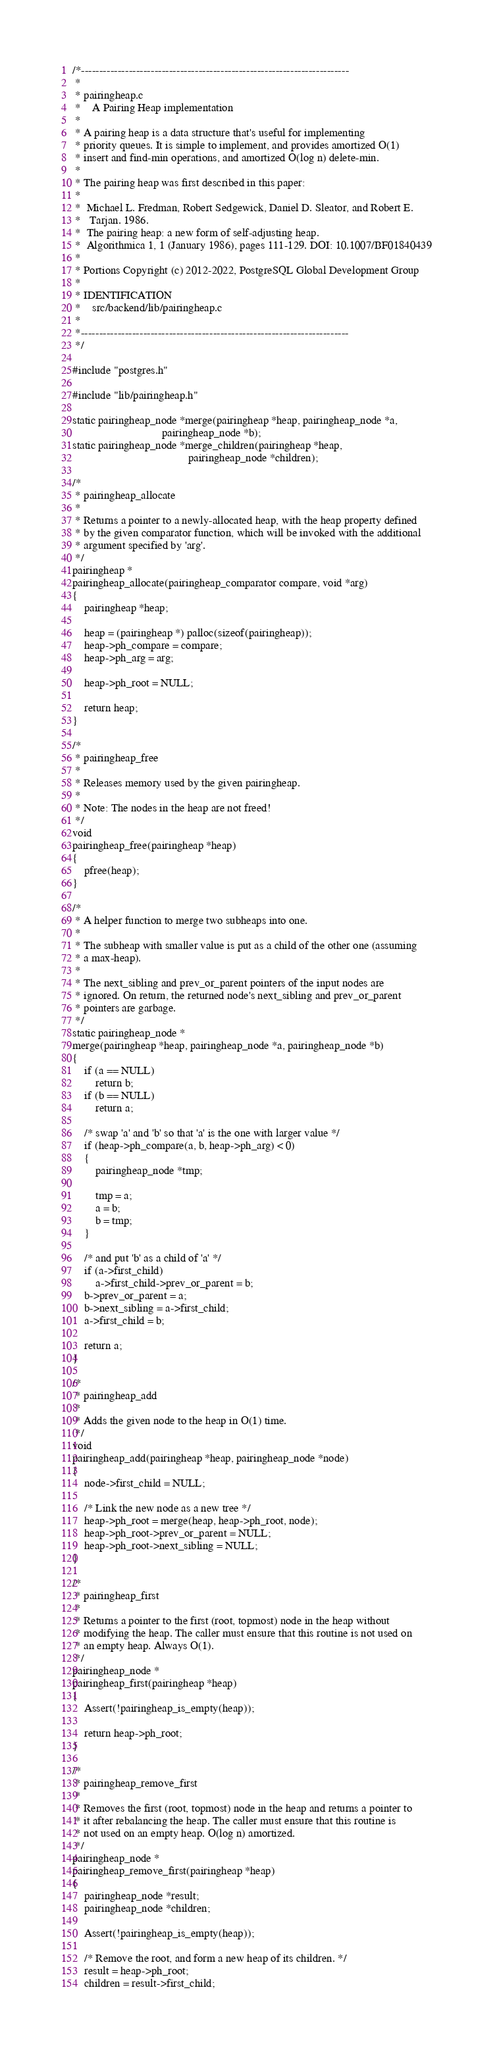<code> <loc_0><loc_0><loc_500><loc_500><_C_>/*-------------------------------------------------------------------------
 *
 * pairingheap.c
 *	  A Pairing Heap implementation
 *
 * A pairing heap is a data structure that's useful for implementing
 * priority queues. It is simple to implement, and provides amortized O(1)
 * insert and find-min operations, and amortized O(log n) delete-min.
 *
 * The pairing heap was first described in this paper:
 *
 *	Michael L. Fredman, Robert Sedgewick, Daniel D. Sleator, and Robert E.
 *	 Tarjan. 1986.
 *	The pairing heap: a new form of self-adjusting heap.
 *	Algorithmica 1, 1 (January 1986), pages 111-129. DOI: 10.1007/BF01840439
 *
 * Portions Copyright (c) 2012-2022, PostgreSQL Global Development Group
 *
 * IDENTIFICATION
 *	  src/backend/lib/pairingheap.c
 *
 *-------------------------------------------------------------------------
 */

#include "postgres.h"

#include "lib/pairingheap.h"

static pairingheap_node *merge(pairingheap *heap, pairingheap_node *a,
							   pairingheap_node *b);
static pairingheap_node *merge_children(pairingheap *heap,
										pairingheap_node *children);

/*
 * pairingheap_allocate
 *
 * Returns a pointer to a newly-allocated heap, with the heap property defined
 * by the given comparator function, which will be invoked with the additional
 * argument specified by 'arg'.
 */
pairingheap *
pairingheap_allocate(pairingheap_comparator compare, void *arg)
{
	pairingheap *heap;

	heap = (pairingheap *) palloc(sizeof(pairingheap));
	heap->ph_compare = compare;
	heap->ph_arg = arg;

	heap->ph_root = NULL;

	return heap;
}

/*
 * pairingheap_free
 *
 * Releases memory used by the given pairingheap.
 *
 * Note: The nodes in the heap are not freed!
 */
void
pairingheap_free(pairingheap *heap)
{
	pfree(heap);
}

/*
 * A helper function to merge two subheaps into one.
 *
 * The subheap with smaller value is put as a child of the other one (assuming
 * a max-heap).
 *
 * The next_sibling and prev_or_parent pointers of the input nodes are
 * ignored. On return, the returned node's next_sibling and prev_or_parent
 * pointers are garbage.
 */
static pairingheap_node *
merge(pairingheap *heap, pairingheap_node *a, pairingheap_node *b)
{
	if (a == NULL)
		return b;
	if (b == NULL)
		return a;

	/* swap 'a' and 'b' so that 'a' is the one with larger value */
	if (heap->ph_compare(a, b, heap->ph_arg) < 0)
	{
		pairingheap_node *tmp;

		tmp = a;
		a = b;
		b = tmp;
	}

	/* and put 'b' as a child of 'a' */
	if (a->first_child)
		a->first_child->prev_or_parent = b;
	b->prev_or_parent = a;
	b->next_sibling = a->first_child;
	a->first_child = b;

	return a;
}

/*
 * pairingheap_add
 *
 * Adds the given node to the heap in O(1) time.
 */
void
pairingheap_add(pairingheap *heap, pairingheap_node *node)
{
	node->first_child = NULL;

	/* Link the new node as a new tree */
	heap->ph_root = merge(heap, heap->ph_root, node);
	heap->ph_root->prev_or_parent = NULL;
	heap->ph_root->next_sibling = NULL;
}

/*
 * pairingheap_first
 *
 * Returns a pointer to the first (root, topmost) node in the heap without
 * modifying the heap. The caller must ensure that this routine is not used on
 * an empty heap. Always O(1).
 */
pairingheap_node *
pairingheap_first(pairingheap *heap)
{
	Assert(!pairingheap_is_empty(heap));

	return heap->ph_root;
}

/*
 * pairingheap_remove_first
 *
 * Removes the first (root, topmost) node in the heap and returns a pointer to
 * it after rebalancing the heap. The caller must ensure that this routine is
 * not used on an empty heap. O(log n) amortized.
 */
pairingheap_node *
pairingheap_remove_first(pairingheap *heap)
{
	pairingheap_node *result;
	pairingheap_node *children;

	Assert(!pairingheap_is_empty(heap));

	/* Remove the root, and form a new heap of its children. */
	result = heap->ph_root;
	children = result->first_child;
</code> 